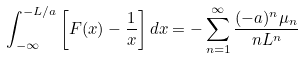Convert formula to latex. <formula><loc_0><loc_0><loc_500><loc_500>\int _ { - \infty } ^ { - L / a } \left [ F ( x ) - \frac { 1 } { x } \right ] d x = - \sum _ { n = 1 } ^ { \infty } \frac { ( - a ) ^ { n } \mu _ { n } } { n L ^ { n } }</formula> 